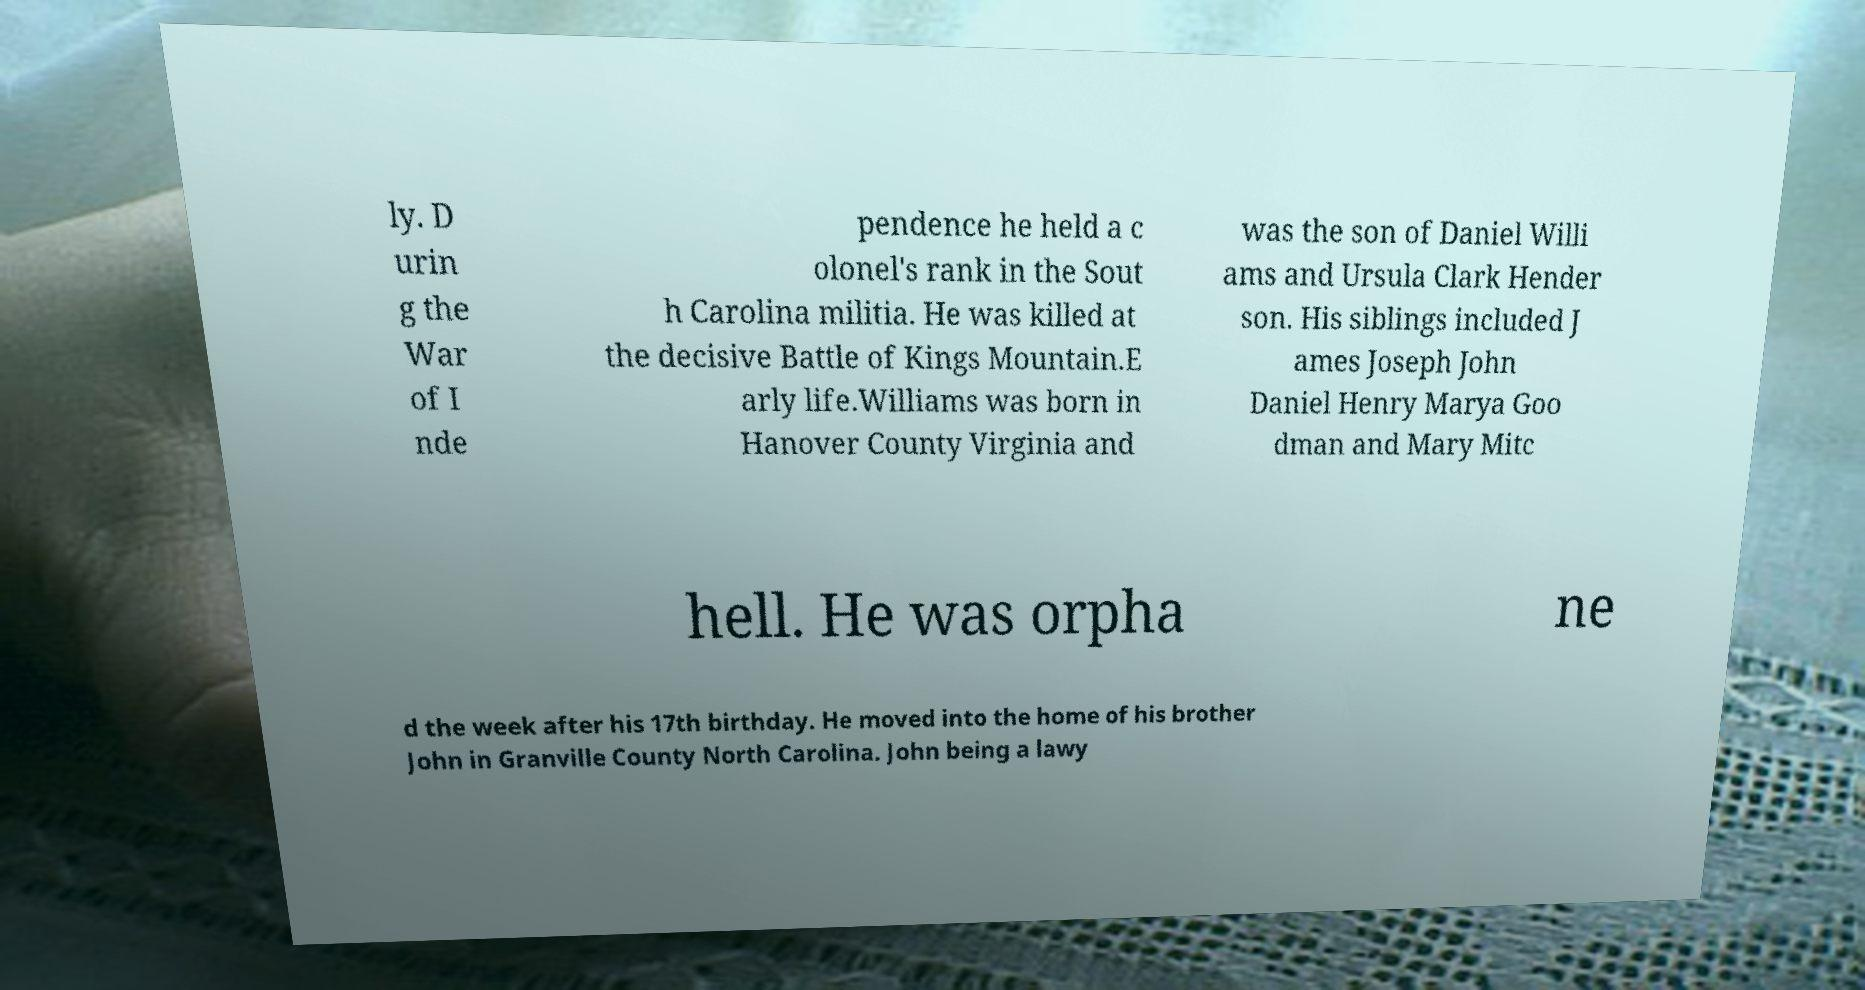Can you read and provide the text displayed in the image?This photo seems to have some interesting text. Can you extract and type it out for me? ly. D urin g the War of I nde pendence he held a c olonel's rank in the Sout h Carolina militia. He was killed at the decisive Battle of Kings Mountain.E arly life.Williams was born in Hanover County Virginia and was the son of Daniel Willi ams and Ursula Clark Hender son. His siblings included J ames Joseph John Daniel Henry Marya Goo dman and Mary Mitc hell. He was orpha ne d the week after his 17th birthday. He moved into the home of his brother John in Granville County North Carolina. John being a lawy 